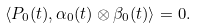Convert formula to latex. <formula><loc_0><loc_0><loc_500><loc_500>\langle P _ { 0 } ( t ) , \alpha _ { 0 } ( t ) \otimes \beta _ { 0 } ( t ) \rangle = 0 .</formula> 